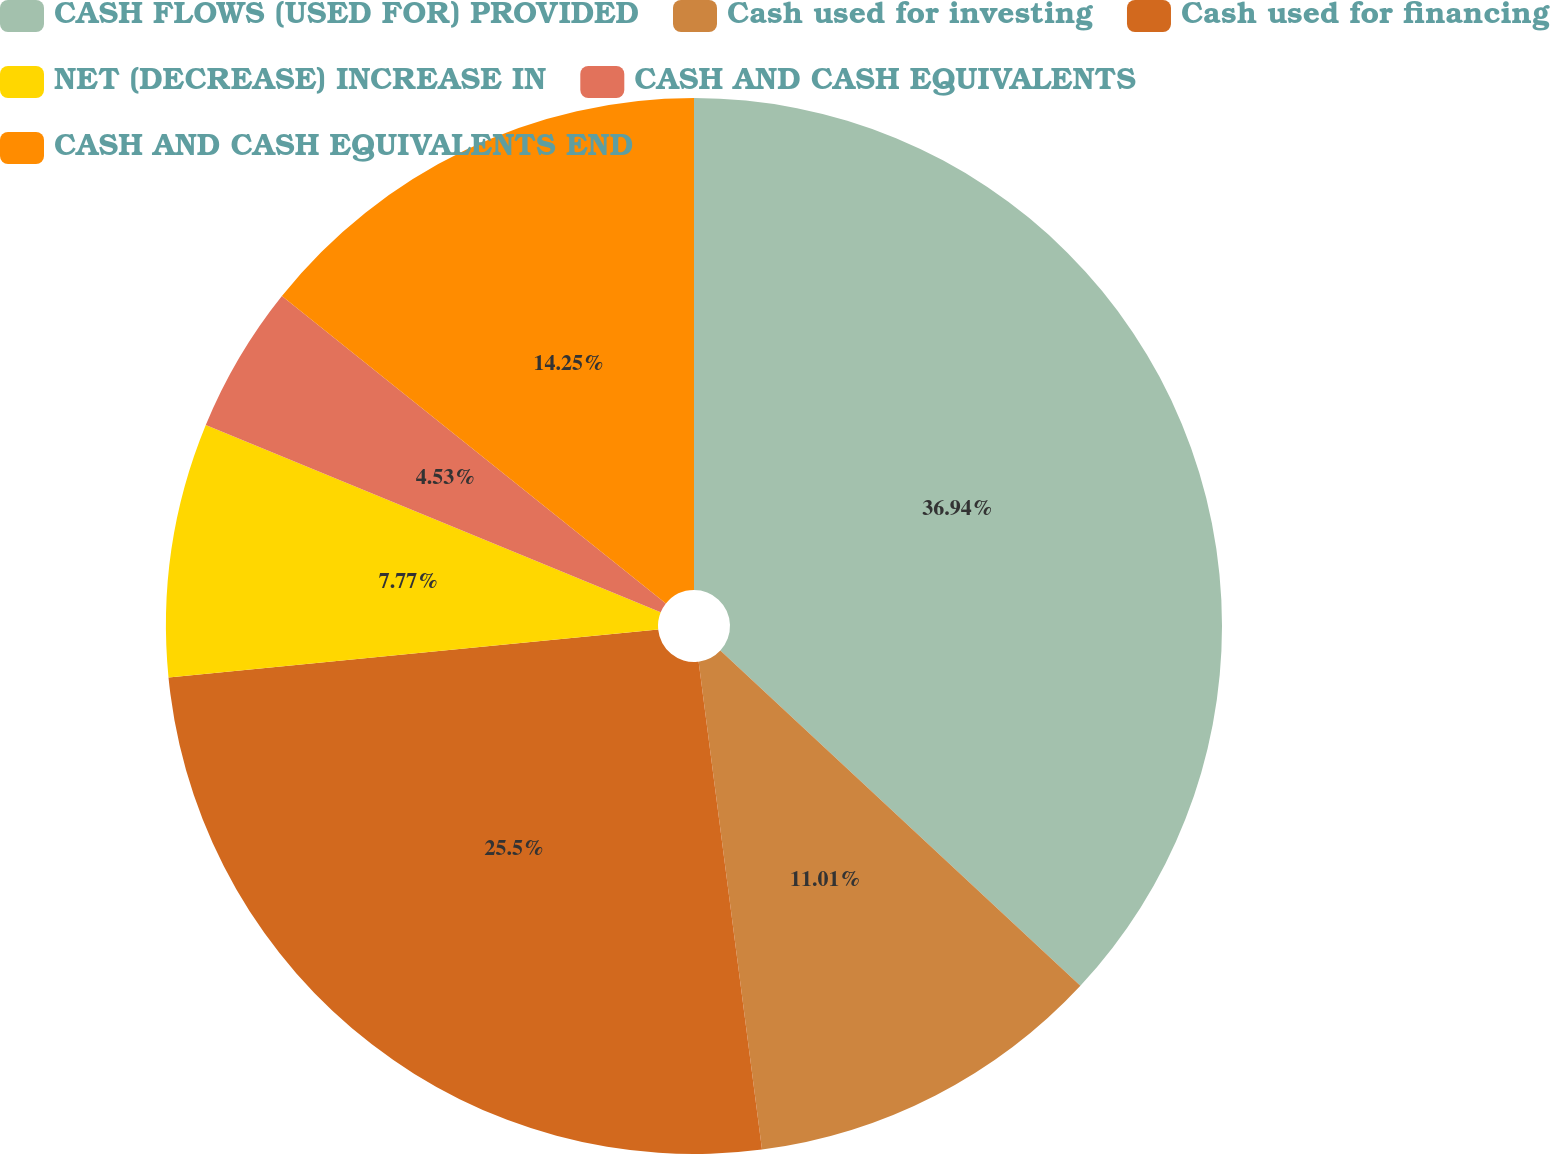Convert chart. <chart><loc_0><loc_0><loc_500><loc_500><pie_chart><fcel>CASH FLOWS (USED FOR) PROVIDED<fcel>Cash used for investing<fcel>Cash used for financing<fcel>NET (DECREASE) INCREASE IN<fcel>CASH AND CASH EQUIVALENTS<fcel>CASH AND CASH EQUIVALENTS END<nl><fcel>36.93%<fcel>11.01%<fcel>25.5%<fcel>7.77%<fcel>4.53%<fcel>14.25%<nl></chart> 